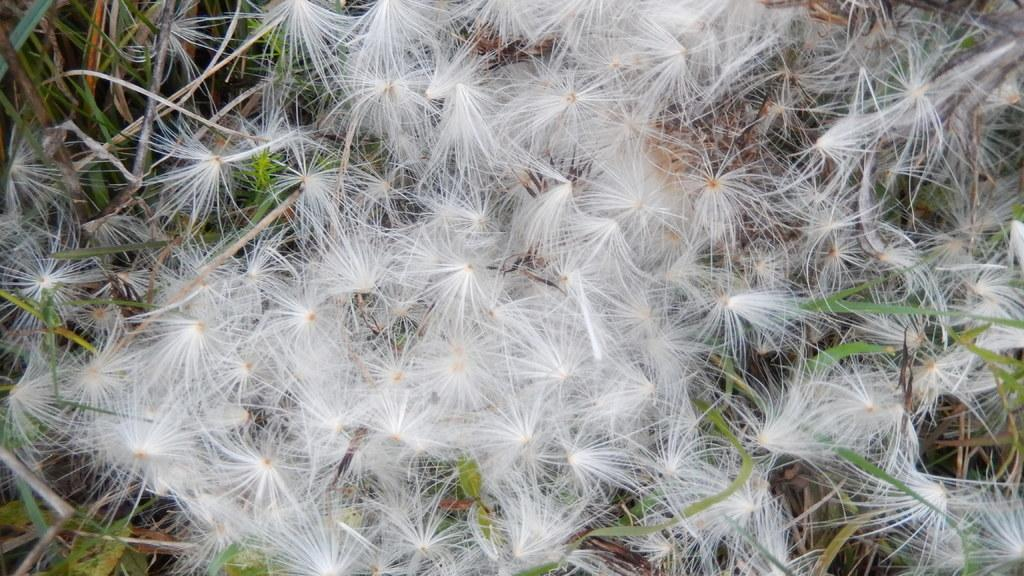What type of plant is in the picture? There is a dandelion in the picture. What is the color of the dandelion? The dandelion is white in color. What type of vegetation is visible in the picture? There is grass visible in the picture. What else can be seen on the floor in the picture? There are twigs on the floor in the picture. What type of instrument is being played in the picture? There is no instrument present in the picture; it features a dandelion, grass, and twigs. Can you see a house in the background of the picture? There is no house visible in the picture. 